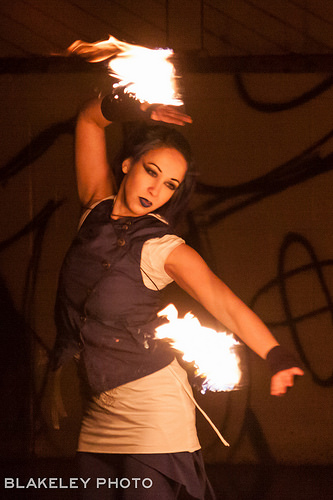<image>
Is the fire on the person? Yes. Looking at the image, I can see the fire is positioned on top of the person, with the person providing support. Where is the fire in relation to the girl? Is it on the girl? Yes. Looking at the image, I can see the fire is positioned on top of the girl, with the girl providing support. Is the fire behind the girl? No. The fire is not behind the girl. From this viewpoint, the fire appears to be positioned elsewhere in the scene. 